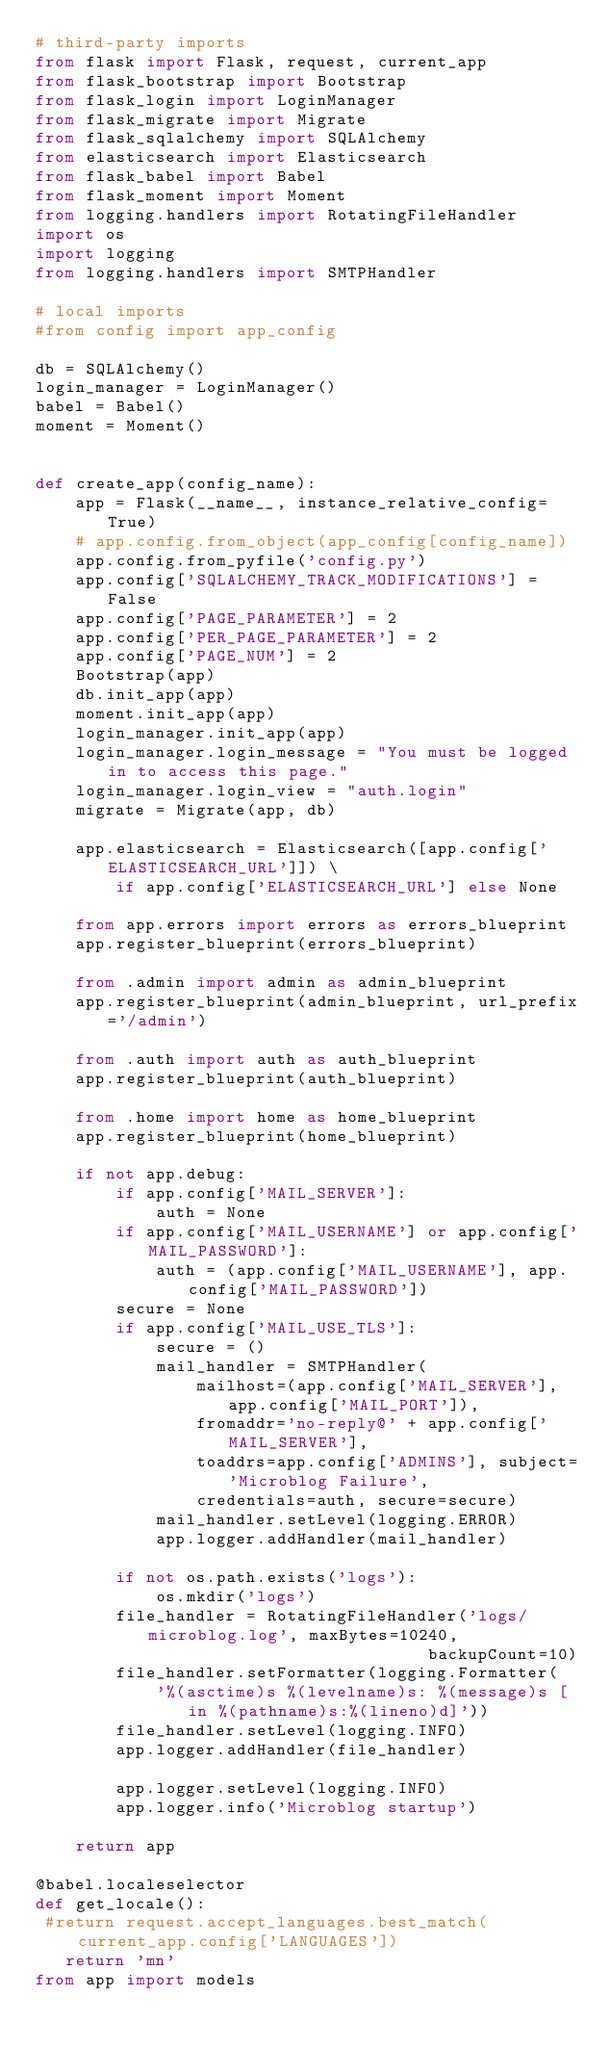<code> <loc_0><loc_0><loc_500><loc_500><_Python_># third-party imports
from flask import Flask, request, current_app
from flask_bootstrap import Bootstrap
from flask_login import LoginManager
from flask_migrate import Migrate
from flask_sqlalchemy import SQLAlchemy
from elasticsearch import Elasticsearch
from flask_babel import Babel
from flask_moment import Moment
from logging.handlers import RotatingFileHandler
import os
import logging
from logging.handlers import SMTPHandler

# local imports
#from config import app_config

db = SQLAlchemy()
login_manager = LoginManager()
babel = Babel()
moment = Moment()


def create_app(config_name):
    app = Flask(__name__, instance_relative_config=True)
    # app.config.from_object(app_config[config_name])
    app.config.from_pyfile('config.py')
    app.config['SQLALCHEMY_TRACK_MODIFICATIONS'] = False
    app.config['PAGE_PARAMETER'] = 2
    app.config['PER_PAGE_PARAMETER'] = 2
    app.config['PAGE_NUM'] = 2
    Bootstrap(app)
    db.init_app(app)
    moment.init_app(app)
    login_manager.init_app(app)
    login_manager.login_message = "You must be logged in to access this page."
    login_manager.login_view = "auth.login"
    migrate = Migrate(app, db)  

    app.elasticsearch = Elasticsearch([app.config['ELASTICSEARCH_URL']]) \
        if app.config['ELASTICSEARCH_URL'] else None
    
    from app.errors import errors as errors_blueprint
    app.register_blueprint(errors_blueprint)

    from .admin import admin as admin_blueprint
    app.register_blueprint(admin_blueprint, url_prefix='/admin')

    from .auth import auth as auth_blueprint
    app.register_blueprint(auth_blueprint)

    from .home import home as home_blueprint
    app.register_blueprint(home_blueprint)

    if not app.debug:
        if app.config['MAIL_SERVER']:
            auth = None
        if app.config['MAIL_USERNAME'] or app.config['MAIL_PASSWORD']:
            auth = (app.config['MAIL_USERNAME'], app.config['MAIL_PASSWORD'])
        secure = None
        if app.config['MAIL_USE_TLS']:
            secure = ()
            mail_handler = SMTPHandler(
                mailhost=(app.config['MAIL_SERVER'], app.config['MAIL_PORT']),
                fromaddr='no-reply@' + app.config['MAIL_SERVER'],
                toaddrs=app.config['ADMINS'], subject='Microblog Failure',
                credentials=auth, secure=secure)
            mail_handler.setLevel(logging.ERROR)
            app.logger.addHandler(mail_handler)

        if not os.path.exists('logs'):
            os.mkdir('logs')
        file_handler = RotatingFileHandler('logs/microblog.log', maxBytes=10240,
                                       backupCount=10)
        file_handler.setFormatter(logging.Formatter(
            '%(asctime)s %(levelname)s: %(message)s [in %(pathname)s:%(lineno)d]'))
        file_handler.setLevel(logging.INFO)
        app.logger.addHandler(file_handler)

        app.logger.setLevel(logging.INFO)
        app.logger.info('Microblog startup')

    return app

@babel.localeselector
def get_locale():
 #return request.accept_languages.best_match(current_app.config['LANGUAGES'])
   return 'mn'
from app import models
</code> 